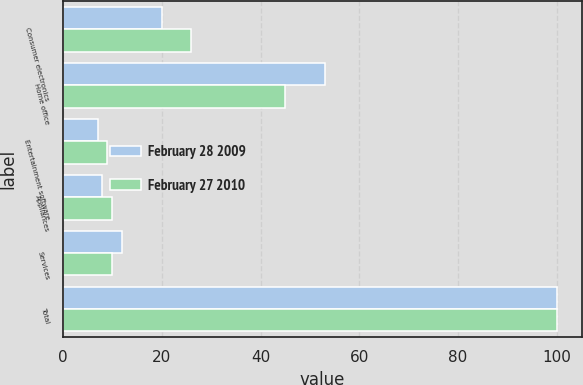<chart> <loc_0><loc_0><loc_500><loc_500><stacked_bar_chart><ecel><fcel>Consumer electronics<fcel>Home office<fcel>Entertainment software<fcel>Appliances<fcel>Services<fcel>Total<nl><fcel>February 28 2009<fcel>20<fcel>53<fcel>7<fcel>8<fcel>12<fcel>100<nl><fcel>February 27 2010<fcel>26<fcel>45<fcel>9<fcel>10<fcel>10<fcel>100<nl></chart> 